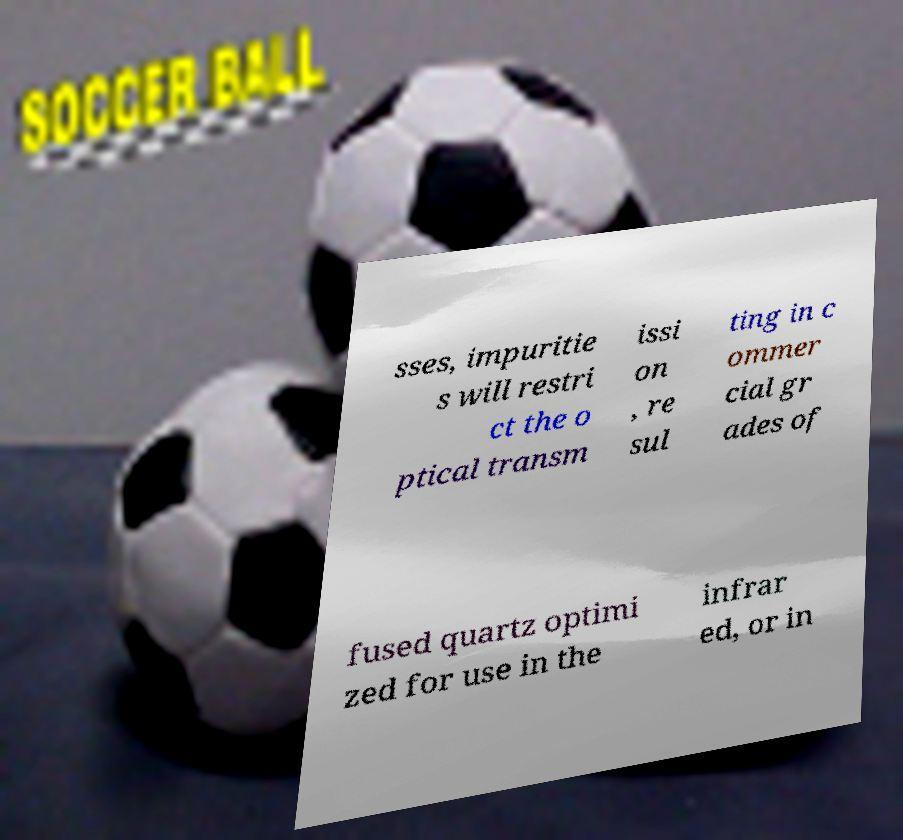Please identify and transcribe the text found in this image. sses, impuritie s will restri ct the o ptical transm issi on , re sul ting in c ommer cial gr ades of fused quartz optimi zed for use in the infrar ed, or in 